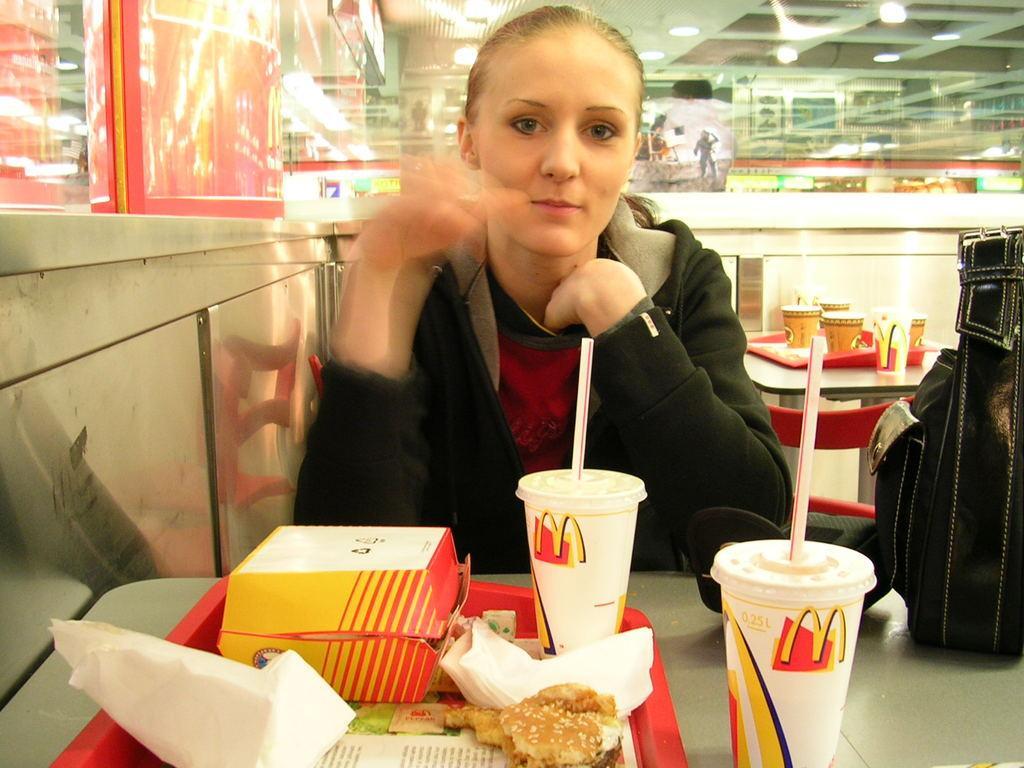In one or two sentences, can you explain what this image depicts? In the center of the image we can see one woman is sitting and she is smiling. And she is wearing a jacket. In front of her, we can see one table. On the table, we can see one bag, one plate, glasses, straws, tissue papers, some food item and a few other objects. In the background there is a wall, table, chairs, banners, lights, glasses and a few other objects. 